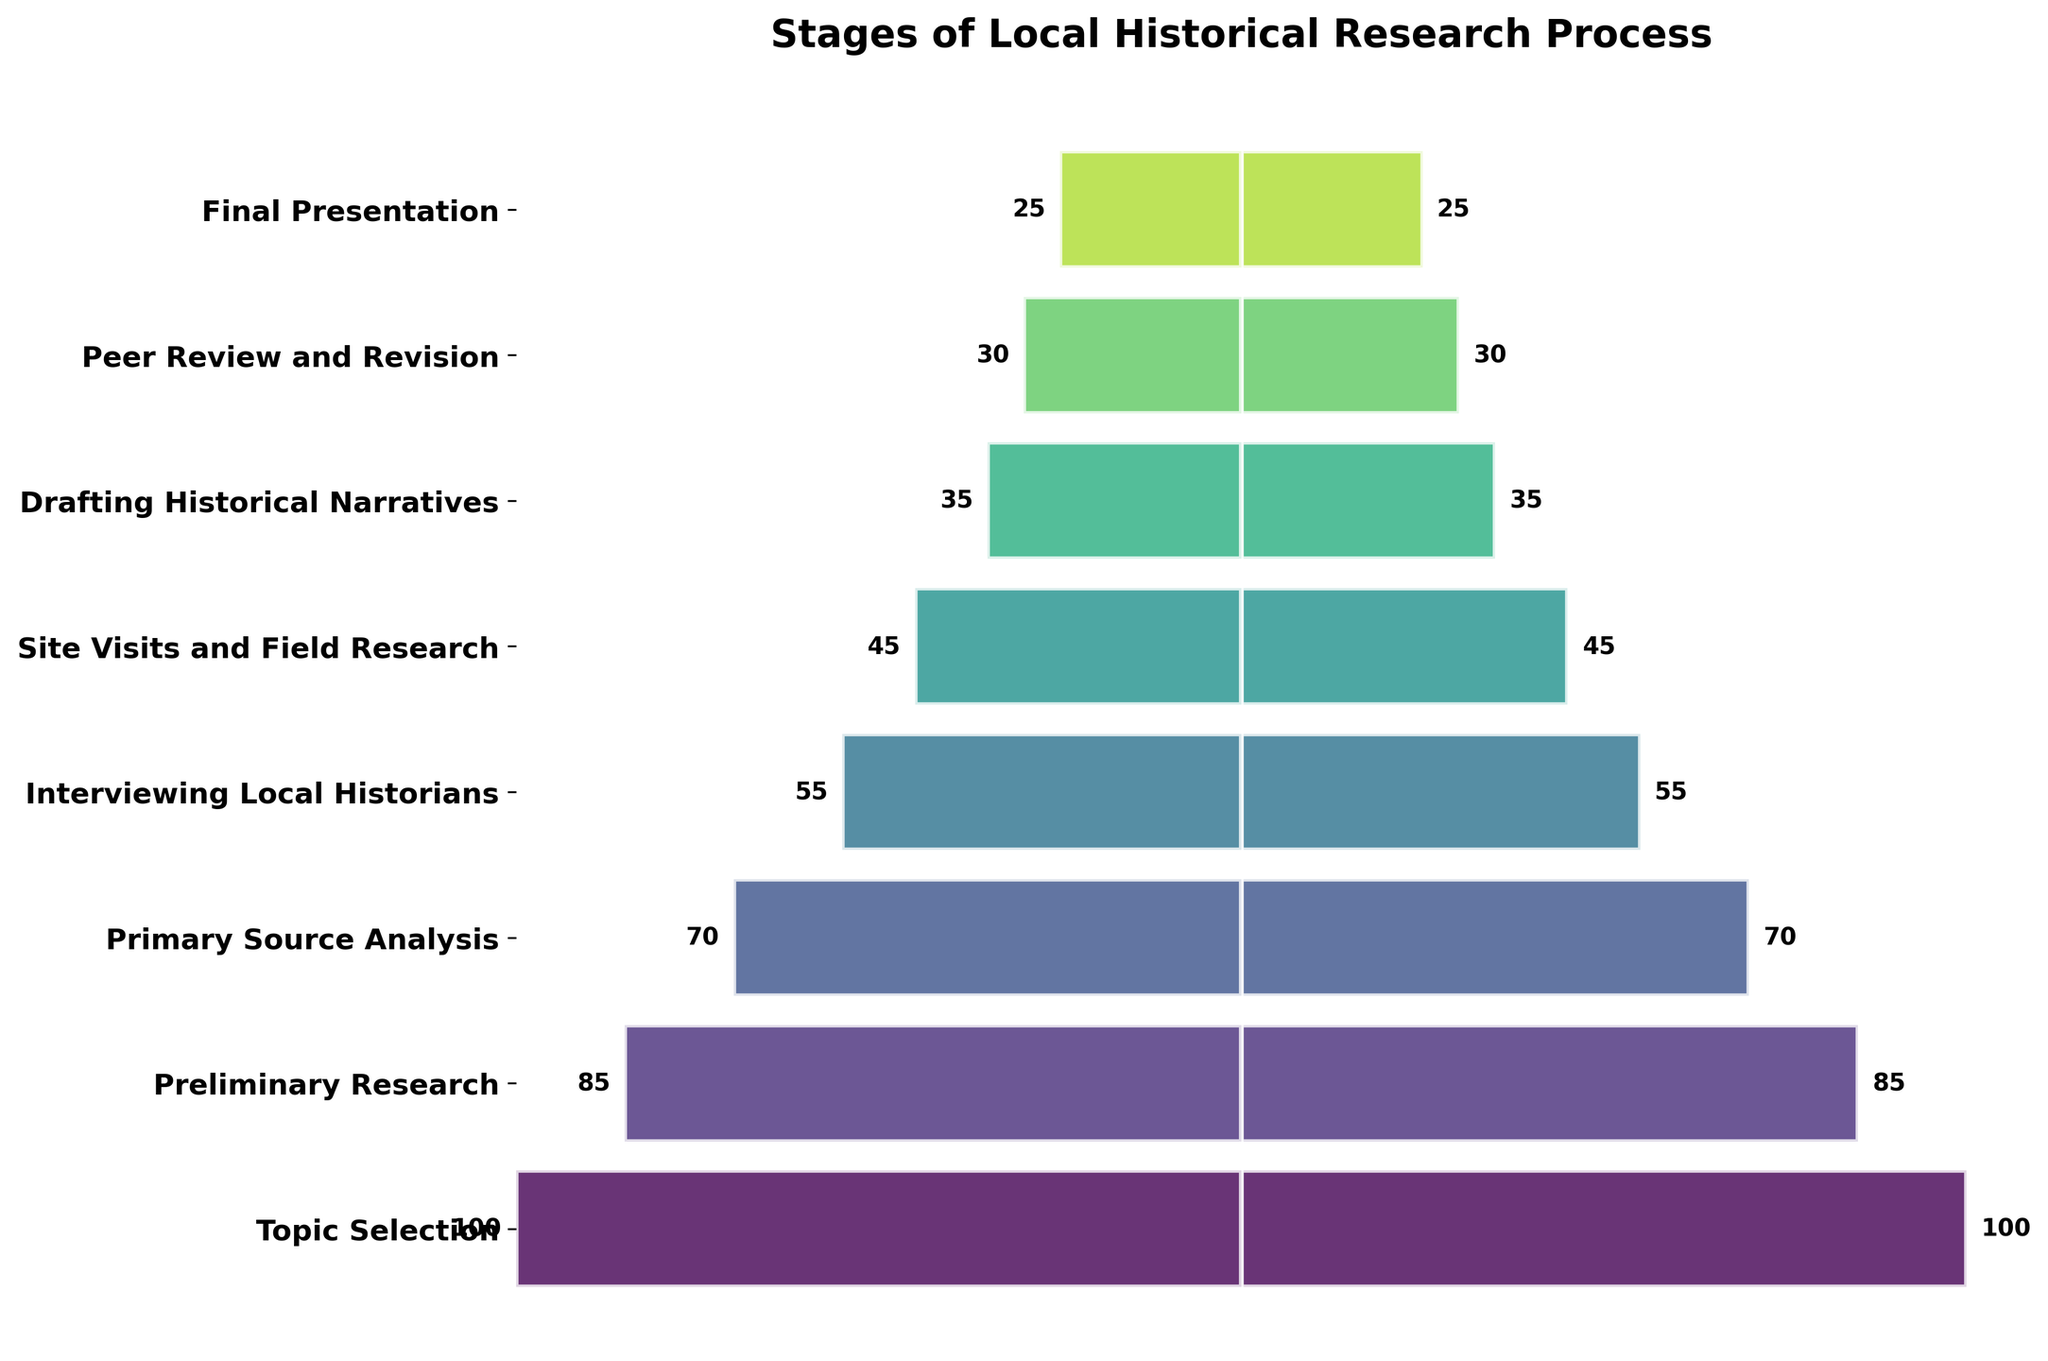What is the title of the figure? The title is prominently displayed at the top of the figure, centered and in bold.
Answer: Stages of Local Historical Research Process Which stage has the highest number of students engaged? The widest bar at the top of the funnel represents the stage with the highest number of students.
Answer: Topic Selection How many students are engaged in the Preliminary Research stage? The value associated with the corresponding bar on the funnel indicates the number of students.
Answer: 85 By how many students does the number of students engaged in Primary Source Analysis differ from Interviewing Local Historians? Subtract the number associated with Interviewing Local Historians (55) from the number associated with Primary Source Analysis (70).
Answer: 15 What is the combined total of students engaged in the Drafting Historical Narratives and Final Presentation stages? Add the number of students for Drafting Historical Narratives (35) and Final Presentation (25).
Answer: 60 What is the average number of students engaged across all stages? Sum the values of all students and divide by the number of stages (8). (100 + 85 + 70 + 55 + 45 + 35 + 30 + 25) / 8
Answer: 55.625 Which stage shows a significant drop in student engagement from the previous stage? Compare the differences between consecutive stages. The largest drop is from Primary Source Analysis (70) to Interviewing Local Historians (55).
Answer: Primary Source Analysis to Interviewing Local Historians How many more students are engaged in Topic Selection compared to Drafting Historical Narratives? Subtract the number for Drafting Historical Narratives (35) from Topic Selection (100).
Answer: 65 Which stages have fewer than 50 students engaged? Identify stages where the value is less than 50 – Site Visits and Field Research (45), Drafting Historical Narratives (35), Peer Review and Revision (30), Final Presentation (25).
Answer: Site Visits and Field Research, Drafting Historical Narratives, Peer Review and Revision, Final Presentation What's the interval difference between students engaged in Preliminary Research and Site Visits and Field Research? Subtract the number for Site Visits and Field Research (45) from Preliminary Research (85).
Answer: 40 